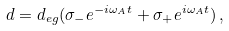Convert formula to latex. <formula><loc_0><loc_0><loc_500><loc_500>d = d _ { e g } ( \sigma _ { - } e ^ { - i \omega _ { A } t } + \sigma _ { + } e ^ { i \omega _ { A } t } ) \, ,</formula> 